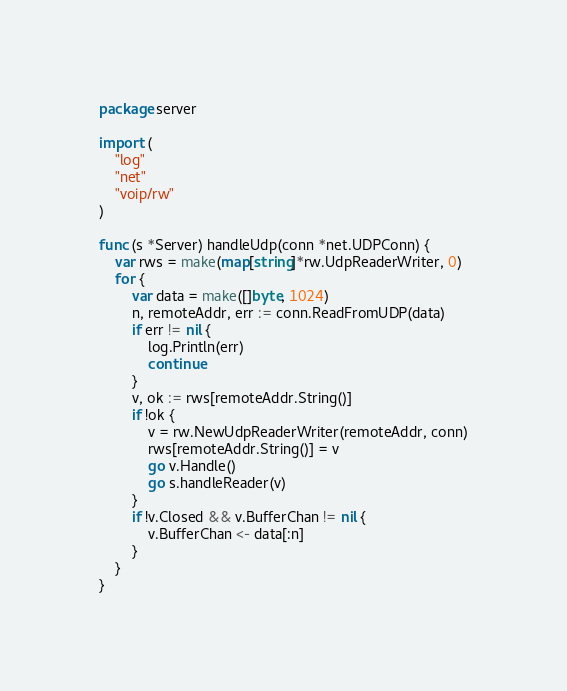<code> <loc_0><loc_0><loc_500><loc_500><_Go_>package server

import (
	"log"
	"net"
	"voip/rw"
)

func (s *Server) handleUdp(conn *net.UDPConn) {
	var rws = make(map[string]*rw.UdpReaderWriter, 0)
	for {
		var data = make([]byte, 1024)
		n, remoteAddr, err := conn.ReadFromUDP(data)
		if err != nil {
			log.Println(err)
			continue
		}
		v, ok := rws[remoteAddr.String()]
		if !ok {
			v = rw.NewUdpReaderWriter(remoteAddr, conn)
			rws[remoteAddr.String()] = v
			go v.Handle()
			go s.handleReader(v)
		}
		if !v.Closed && v.BufferChan != nil {
			v.BufferChan <- data[:n]
		}
	}
}
</code> 